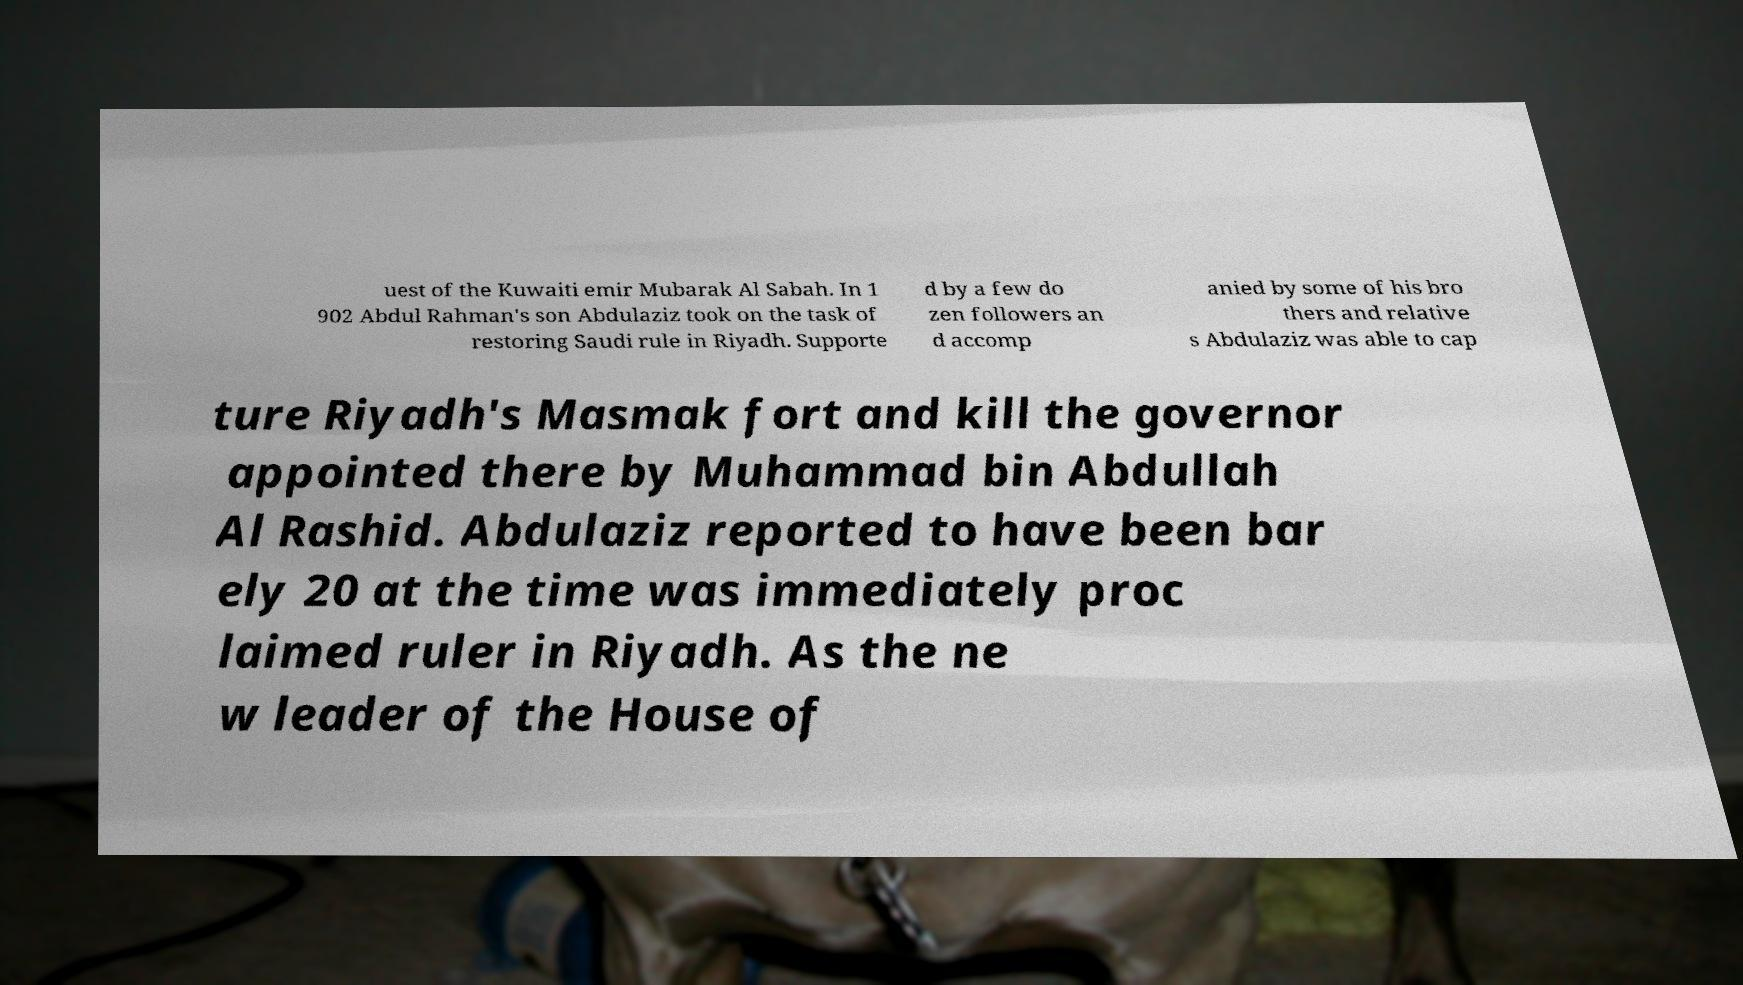Please identify and transcribe the text found in this image. uest of the Kuwaiti emir Mubarak Al Sabah. In 1 902 Abdul Rahman's son Abdulaziz took on the task of restoring Saudi rule in Riyadh. Supporte d by a few do zen followers an d accomp anied by some of his bro thers and relative s Abdulaziz was able to cap ture Riyadh's Masmak fort and kill the governor appointed there by Muhammad bin Abdullah Al Rashid. Abdulaziz reported to have been bar ely 20 at the time was immediately proc laimed ruler in Riyadh. As the ne w leader of the House of 